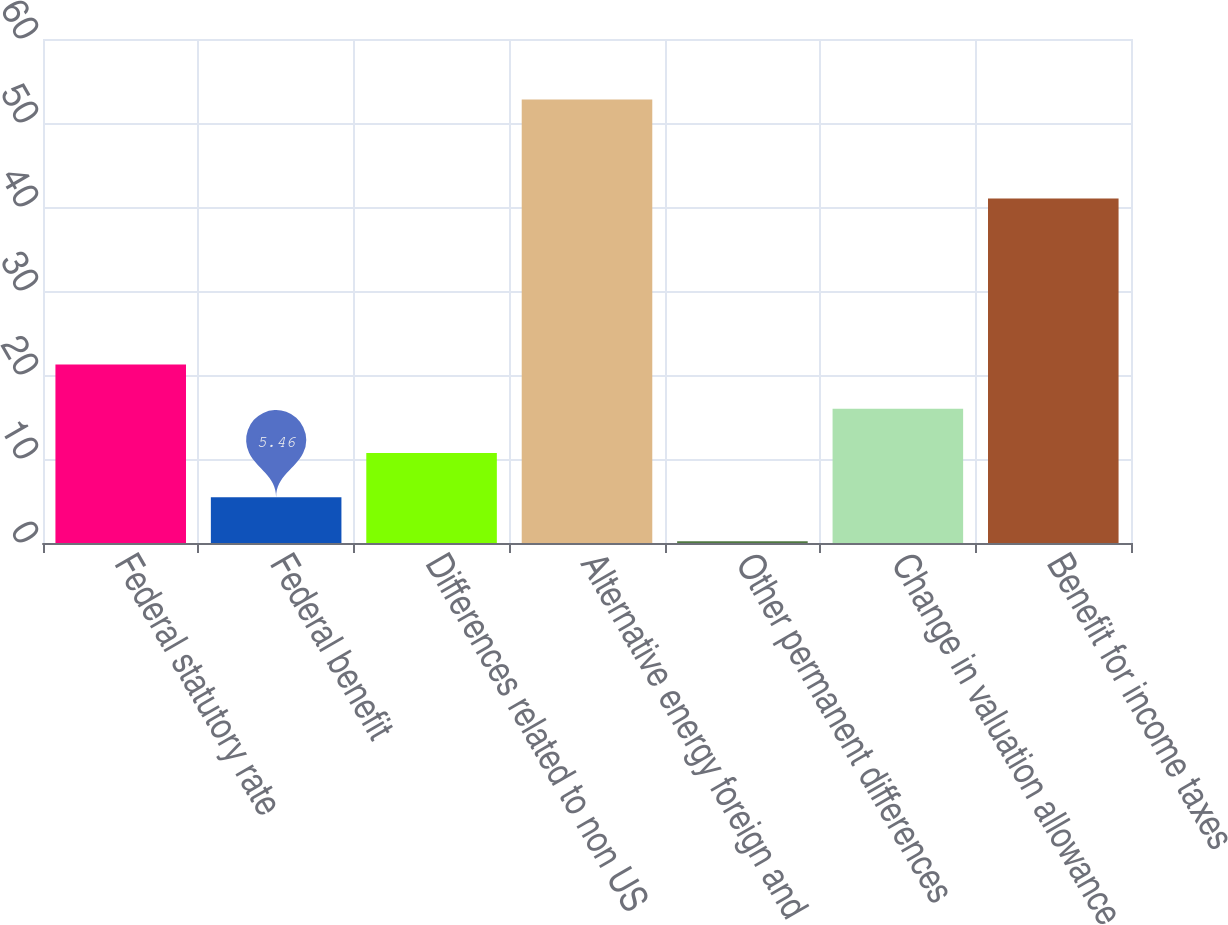Convert chart to OTSL. <chart><loc_0><loc_0><loc_500><loc_500><bar_chart><fcel>Federal statutory rate<fcel>Federal benefit<fcel>Differences related to non US<fcel>Alternative energy foreign and<fcel>Other permanent differences<fcel>Change in valuation allowance<fcel>Benefit for income taxes<nl><fcel>21.24<fcel>5.46<fcel>10.72<fcel>52.8<fcel>0.2<fcel>15.98<fcel>41<nl></chart> 